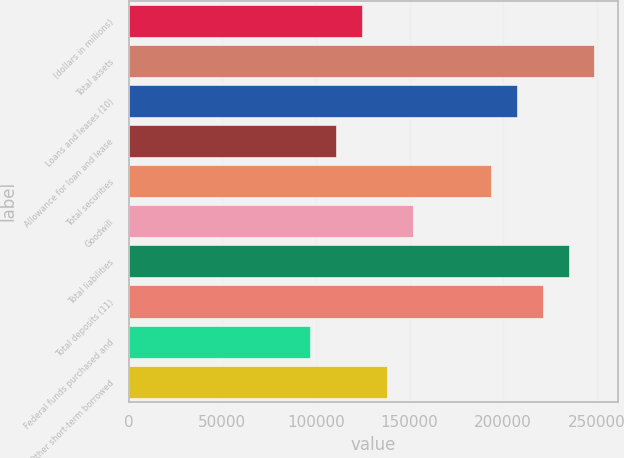<chart> <loc_0><loc_0><loc_500><loc_500><bar_chart><fcel>(dollars in millions)<fcel>Total assets<fcel>Loans and leases (10)<fcel>Allowance for loan and lease<fcel>Total securities<fcel>Goodwill<fcel>Total liabilities<fcel>Total deposits (11)<fcel>Federal funds purchased and<fcel>Other short-term borrowed<nl><fcel>124387<fcel>248773<fcel>207311<fcel>110567<fcel>193491<fcel>152029<fcel>234953<fcel>221132<fcel>96745.9<fcel>138208<nl></chart> 